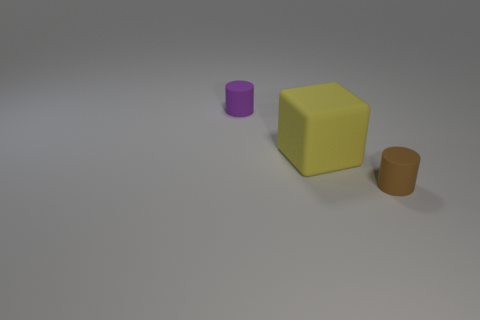There is a object that is both on the left side of the brown object and in front of the purple thing; what is it made of?
Provide a succinct answer. Rubber. What is the size of the matte cylinder behind the rubber cylinder that is on the right side of the tiny object that is behind the big yellow matte block?
Ensure brevity in your answer.  Small. Does the brown rubber object have the same shape as the large yellow thing that is to the right of the purple rubber cylinder?
Give a very brief answer. No. What number of matte things are both on the left side of the brown object and in front of the purple object?
Keep it short and to the point. 1. What number of brown objects are small cylinders or big matte things?
Offer a very short reply. 1. There is a tiny matte object that is on the right side of the cylinder that is behind the tiny matte object that is in front of the tiny purple rubber cylinder; what is its color?
Provide a short and direct response. Brown. There is a matte cylinder in front of the large thing; is there a small cylinder that is behind it?
Keep it short and to the point. Yes. Do the tiny matte object in front of the yellow rubber cube and the purple thing have the same shape?
Make the answer very short. Yes. Are there any other things that are the same shape as the large yellow object?
Your answer should be compact. No. How many cubes are cyan objects or yellow objects?
Keep it short and to the point. 1. 